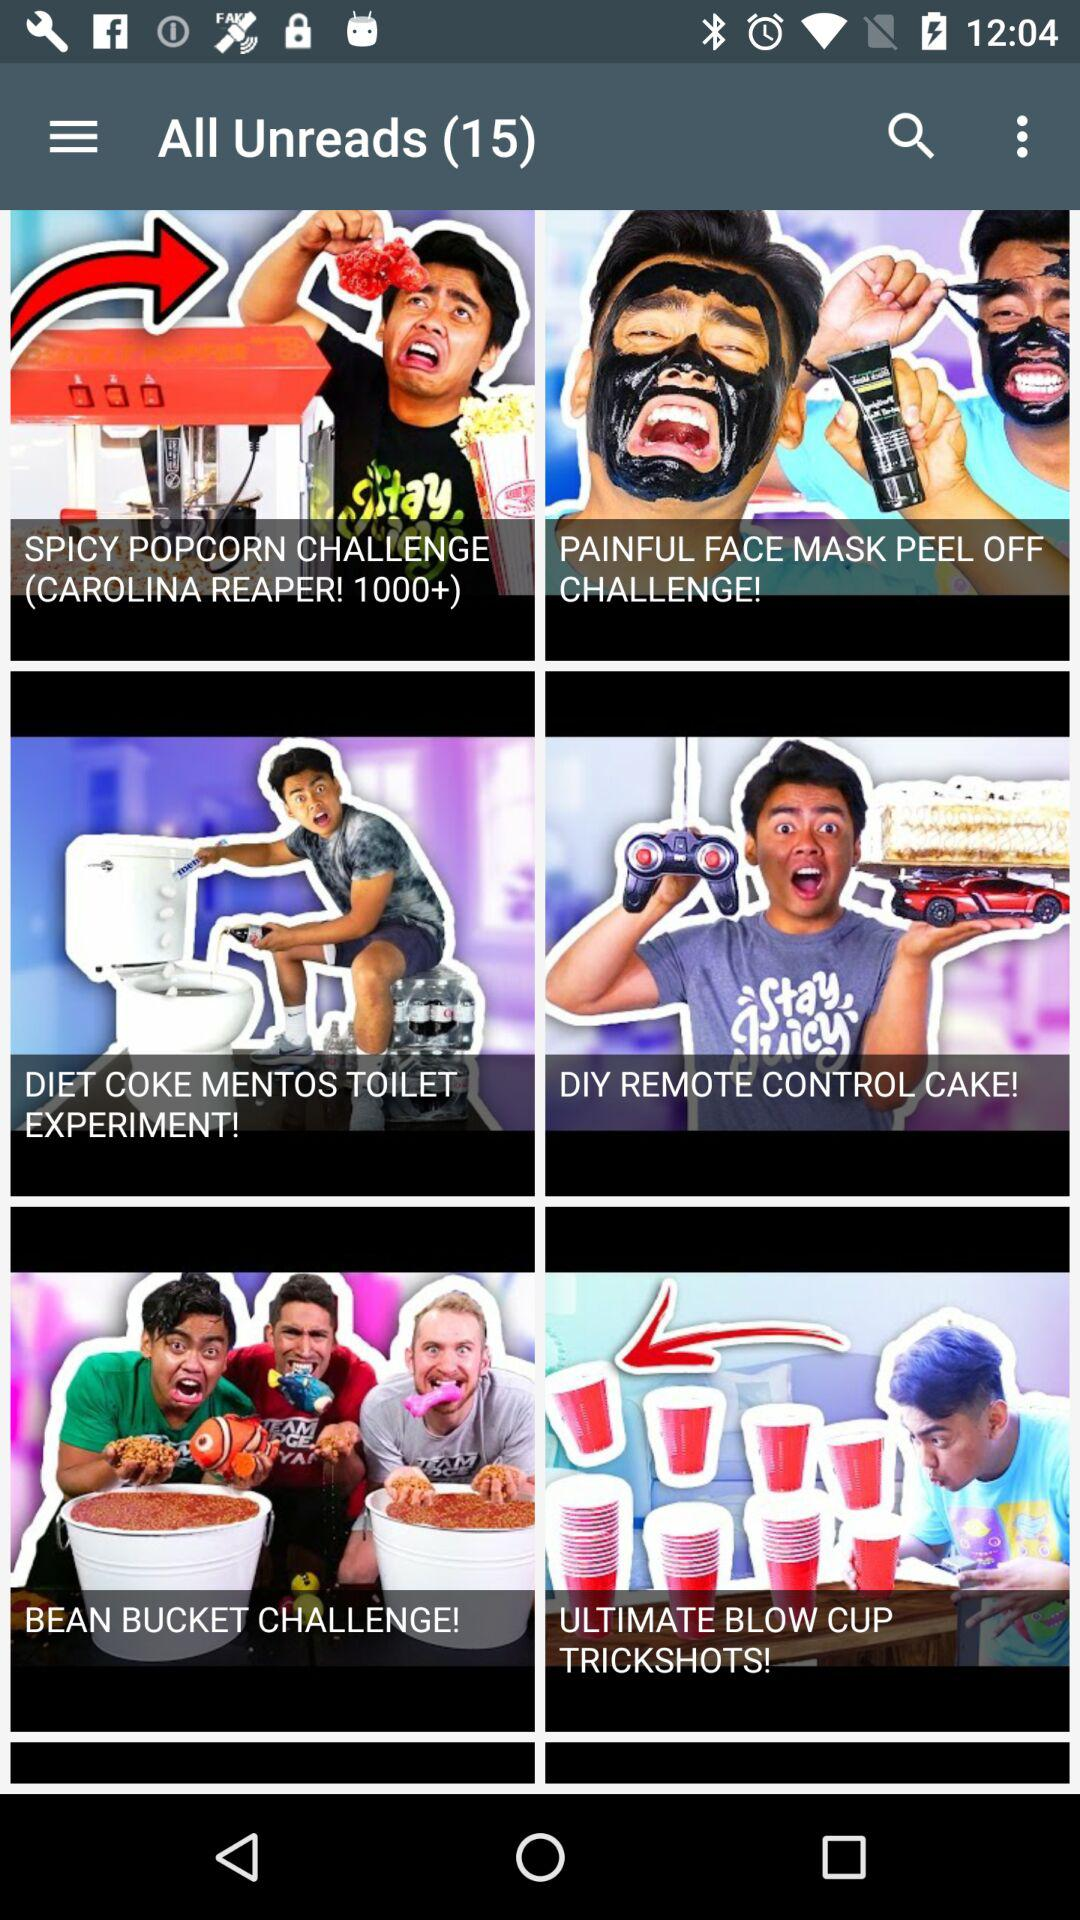How many unread notifications are there? There are 15 unread notifications. 